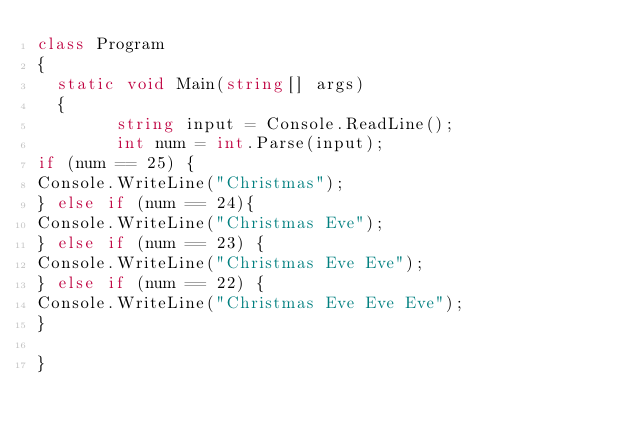Convert code to text. <code><loc_0><loc_0><loc_500><loc_500><_C#_>class Program
{
	static void Main(string[] args)
	{
        string input = Console.ReadLine();
        int num = int.Parse(input);
if (num == 25) {
Console.WriteLine("Christmas");
} else if (num == 24){
Console.WriteLine("Christmas Eve");
} else if (num == 23) {
Console.WriteLine("Christmas Eve Eve");
} else if (num == 22) {
Console.WriteLine("Christmas Eve Eve Eve");
}

}</code> 